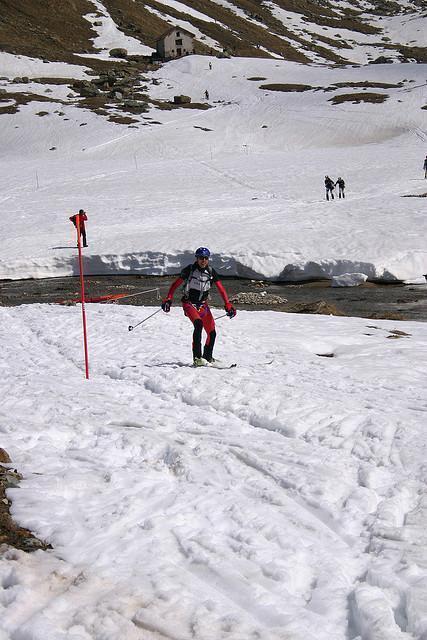What time of day is this?
Choose the correct response and explain in the format: 'Answer: answer
Rationale: rationale.'
Options: Dawn, afternoon, midday, dusk. Answer: midday.
Rationale: The sun is directly overhead, casting only small shadows 